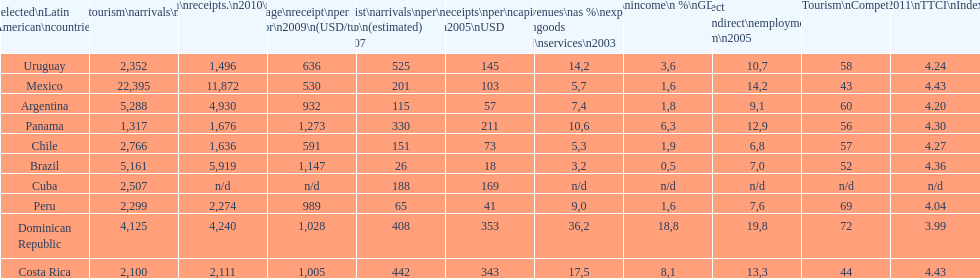What country had the most receipts per capita in 2005? Dominican Republic. 